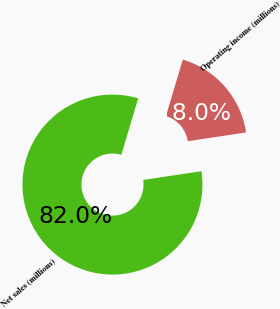Convert chart. <chart><loc_0><loc_0><loc_500><loc_500><pie_chart><fcel>Net sales (millions)<fcel>Operating income (millions)<nl><fcel>81.99%<fcel>18.01%<nl></chart> 